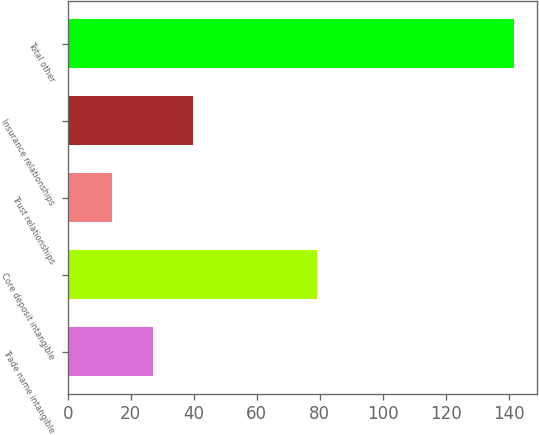<chart> <loc_0><loc_0><loc_500><loc_500><bar_chart><fcel>Trade name intangible<fcel>Core deposit intangible<fcel>Trust relationships<fcel>Insurance relationships<fcel>Total other<nl><fcel>26.95<fcel>79.2<fcel>14.2<fcel>39.7<fcel>141.7<nl></chart> 